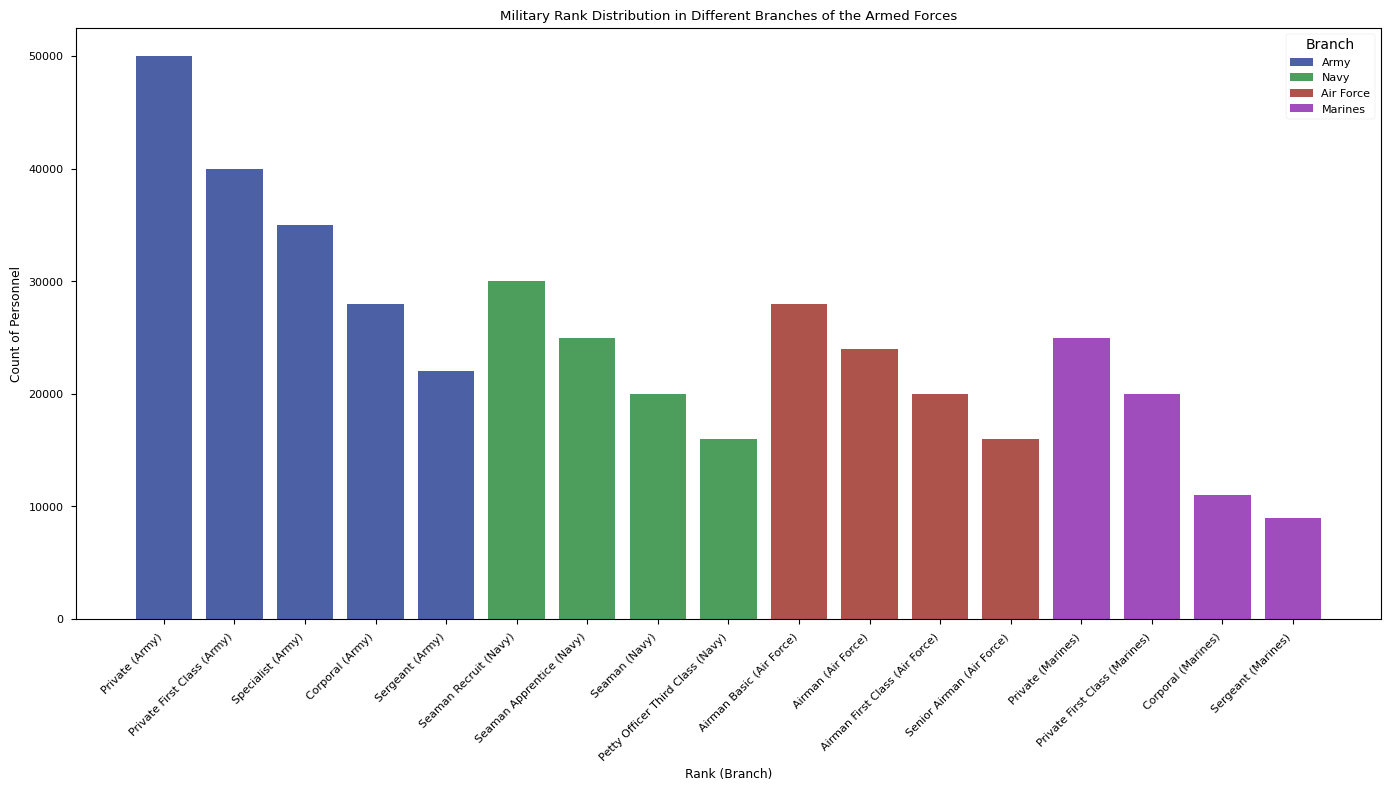What's the branch with the highest count for the rank of 'Sergeant'? To find the branch with the highest count for the rank of 'Sergeant,' locate the bars for the 'Sergeant' rank in each branch (Army, Navy, Air Force, Marines) and identify which bar is the tallest.
Answer: Army Which rank has the highest years of service among all listed ranks? To determine the rank with the highest years of service, check the text annotation mentioning "Years of Service" and identify which rank has the maximum value, which is likely highlighted in the chart.
Answer: Sergeant Major of the (Branch) How does the count of 'Private' compare to 'Corporal' in the Army? Look for the bars corresponding to 'Private' and 'Corporal' within the Army section and compare their heights. The 'Private' bar height for the Army is much taller than the 'Corporal' bar.
Answer: 'Private' is higher What's the average years of service for the top 5 ranks in the Navy? Identify the top 5 ranks in the Navy from the highlighted ranks, sum their average years of service and divide by 5 to get the mean. The ranks are: Seaman Recruit (1), Seaman Apprentice (2), Seaman (3), Petty Officer Third Class (4), Petty Officer Second Class (6). The calculation is (1+2+3+4+6)/5.
Answer: 3.2 years Which branch has more personnel at 'Private First Class', Army or Marines? Compare the bars for 'Private First Class' in the Army and Marines sections. The height of the respective bars indicates the count, showing which branch has more.
Answer: Army What is the total count of personnel for all the 'Master Sergeant' ranks across all branches? Add up the count values for the 'Master Sergeant' rank in each branch: Army (6000), Navy (not listed), Air Force (5000), Marines (2000). Sum them to get the total.
Answer: 13000 What color is used to highlight the average years of service annotation? Check the color used for the text and arrow associated with the "Years of Service" annotation. The instructions indicate the annotation should be in a visibly distinct color.
Answer: Red Is the number of 'Private' personnel greater than the combined number of 'Sergeant' and 'Corporal' personnel in the Army? Sum the 'Sergeant' (22000) and 'Corporal' (28000) personnel and compare this total (50000) to the 'Private' personnel number (50000) in the Army. In this case, both are equal.
Answer: No, it is equal How do the counts of 'Seaman' in the Navy compare with 'Airman' in the Air Force? Look at the height of the 'Seaman' bar in the Navy and the 'Airman' bar in the Air Force; compare their heights to see the larger value.
Answer: Navy 'Seaman' is higher 